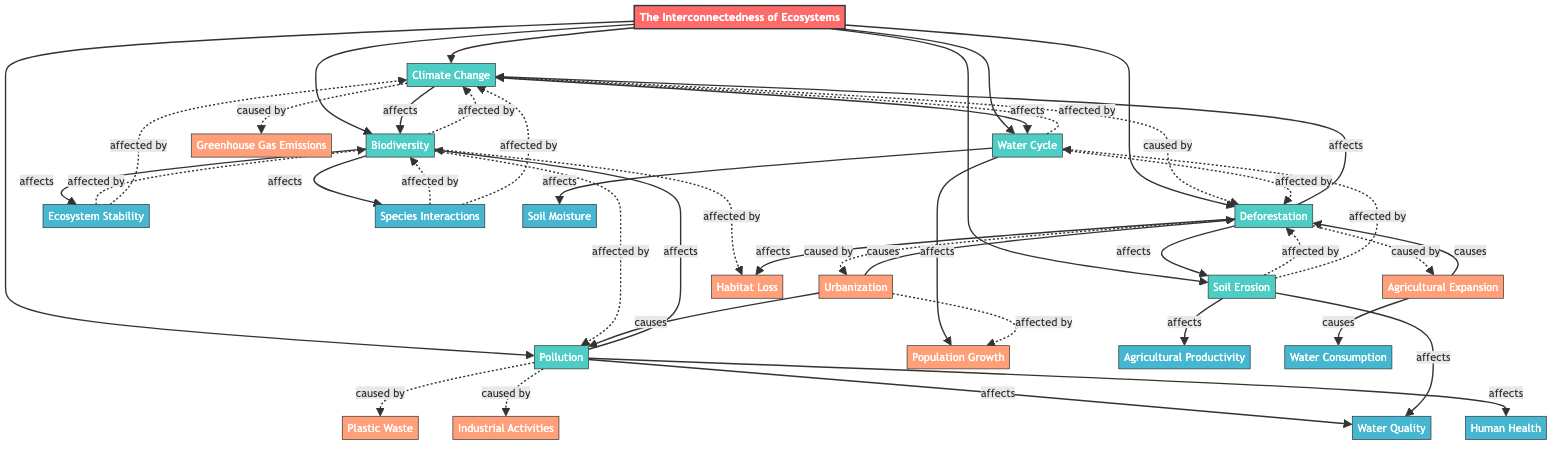What are the main components of the ecosystem in this diagram? The main components identified are Climate Change, Biodiversity, Water Cycle, Deforestation, Pollution, Soil Erosion, Ecosystem Stability, and Species Interactions. Each of these components connects with others, showing their interdependencies.
Answer: Climate Change, Biodiversity, Water Cycle, Deforestation, Pollution, Soil Erosion, Ecosystem Stability, Species Interactions How many elements are affected by Climate Change? Climate Change affects two elements: Biodiversity and Water Cycle. This can be deduced through the arrows pointing out from Climate Change to these two components.
Answer: 2 What causes Deforestation? Deforestation is caused by Agricultural Expansion and Urbanization, as indicated by the dashed arrows leading to Deforestation in the diagram.
Answer: Agricultural Expansion, Urbanization What does Soil Erosion affect? Soil Erosion affects Agricultural Productivity and Water Quality. This is evident from the arrows pointing out from the Soil Erosion node to these two outcomes.
Answer: Agricultural Productivity, Water Quality What types of activities lead to Pollution? Pollution is caused by Industrial Activities and Plastic Waste, as clearly shown by the dashed arrows leading into the Pollution node.
Answer: Industrial Activities, Plastic Waste Which components are affected by Biodiversity? Biodiversity affects Ecosystem Stability and Species Interactions, as indicated by the arrows that show the direction of effect from Biodiversity to these two components.
Answer: Ecosystem Stability, Species Interactions If Urbanization increases, what will it cause? Urbanization causes Deforestation and Pollution, which is indicated by the solid arrows pointing from Urbanization to these two nodes.
Answer: Deforestation, Pollution Which factor shows the highest impact on Biodiversity? The highest impact on Biodiversity appears to come from Habitat Loss, Climate Change, and Pollution. The arrows leading into Biodiversity illustrate that these three factors significantly affect its state.
Answer: Habitat Loss, Climate Change, Pollution How many elements are affected by Water Cycle? Water Cycle affects two elements: Soil Moisture and Plant Growth. These are the components that receive an effect from the Water Cycle as shown by the arrows emanating from it.
Answer: 2 